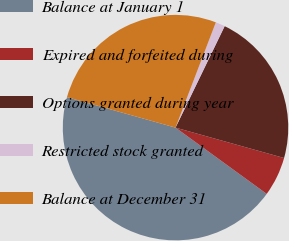Convert chart to OTSL. <chart><loc_0><loc_0><loc_500><loc_500><pie_chart><fcel>Balance at January 1<fcel>Expired and forfeited during<fcel>Options granted during year<fcel>Restricted stock granted<fcel>Balance at December 31<nl><fcel>44.36%<fcel>5.66%<fcel>22.17%<fcel>1.36%<fcel>26.47%<nl></chart> 